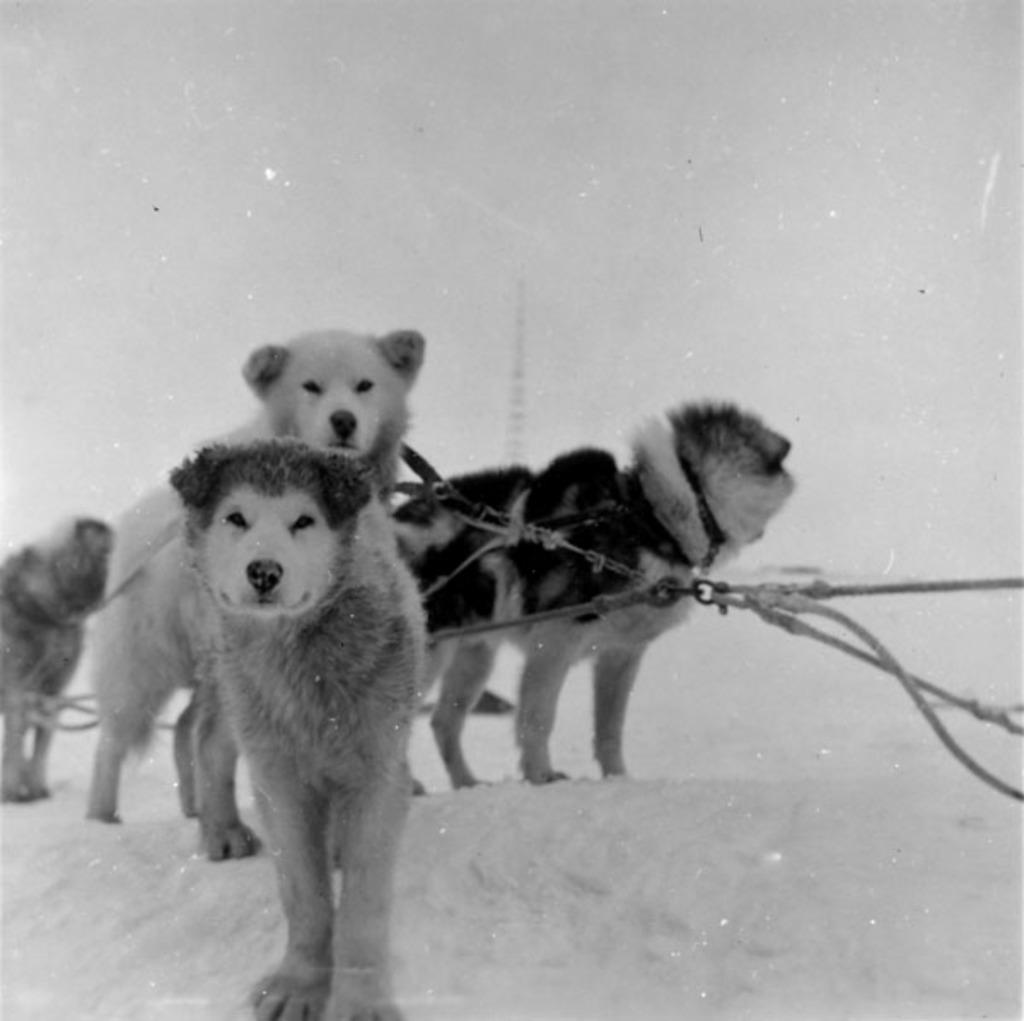What animals are present in the image? There are dogs in the image. Where are the dogs located? The dogs are on the snow. What is the color scheme of the image? The image is black and white. What can be seen in the background of the image? There is a sky visible in the background of the image. What type of chin can be seen on the stone in the image? There is no chin or stone present in the image; it features dogs on the snow. What office supplies can be seen in the image? There are no office supplies present in the image. 